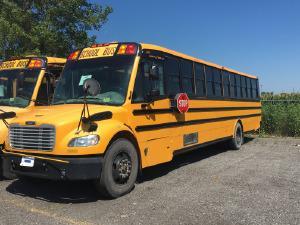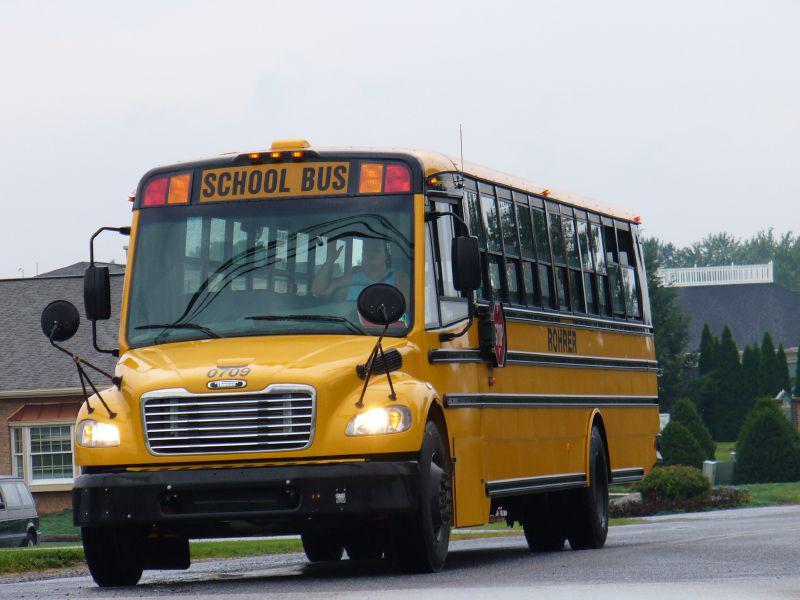The first image is the image on the left, the second image is the image on the right. For the images shown, is this caption "One of the images features two school buses beside each other." true? Answer yes or no. Yes. The first image is the image on the left, the second image is the image on the right. Analyze the images presented: Is the assertion "All the school buses in the images are facing to the left." valid? Answer yes or no. Yes. 